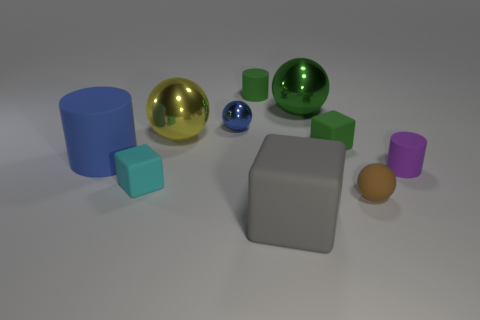There is a matte block behind the purple cylinder; does it have the same size as the brown matte object?
Your response must be concise. Yes. There is a large sphere that is to the left of the small green object left of the big rubber object that is on the right side of the small green matte cylinder; what is its material?
Ensure brevity in your answer.  Metal. The small sphere on the left side of the tiny green rubber object to the right of the large gray rubber cube is made of what material?
Ensure brevity in your answer.  Metal. Are there fewer big blue cylinders right of the large gray rubber object than big blue metal cubes?
Offer a terse response. No. The rubber thing behind the yellow metallic sphere has what shape?
Ensure brevity in your answer.  Cylinder. Is the size of the blue rubber cylinder the same as the green rubber thing that is on the right side of the gray block?
Provide a short and direct response. No. Are there any yellow objects that have the same material as the cyan thing?
Offer a terse response. No. What number of cubes are either large purple metal objects or green matte things?
Your response must be concise. 1. There is a purple matte cylinder right of the blue cylinder; are there any small green cubes that are on the right side of it?
Keep it short and to the point. No. Is the number of blue rubber objects less than the number of cylinders?
Give a very brief answer. Yes. 